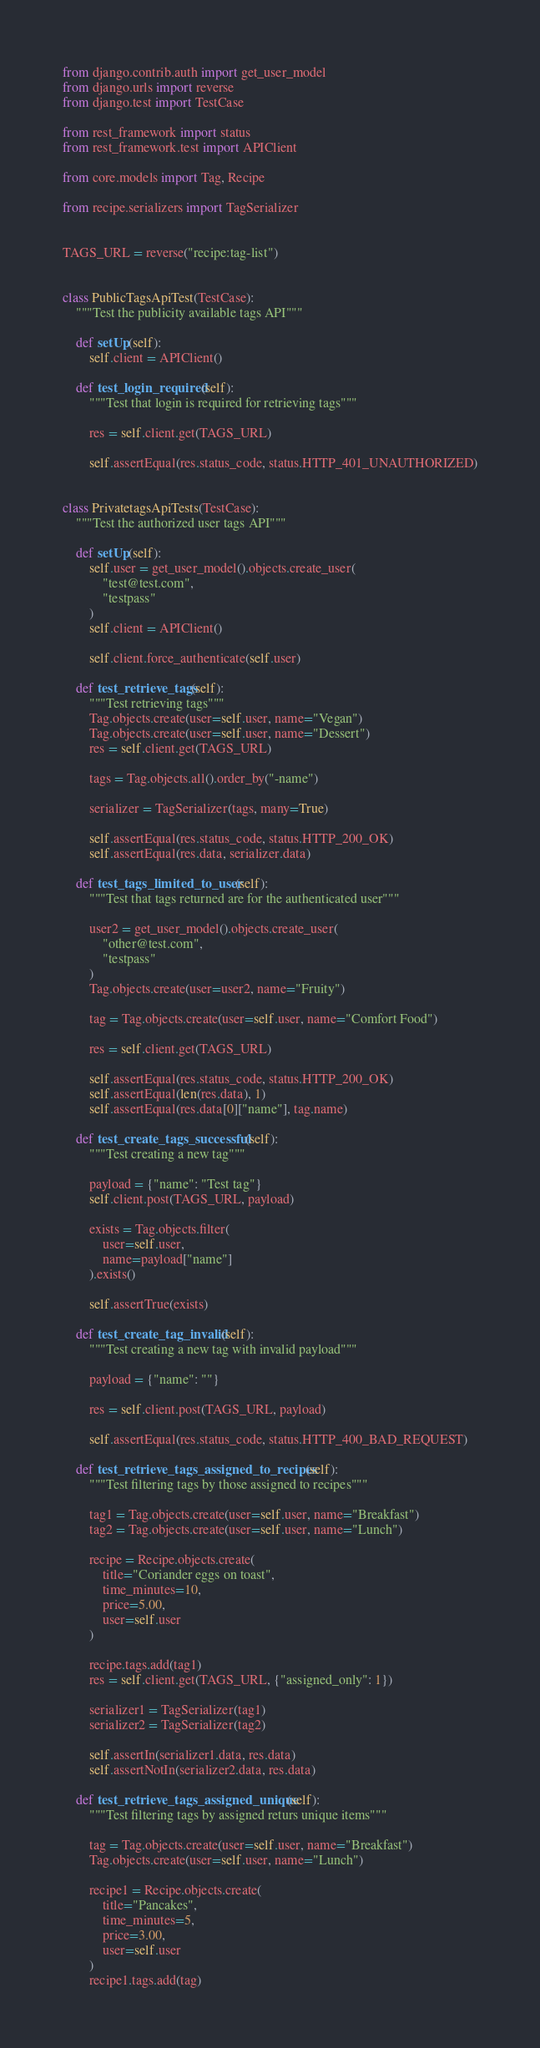<code> <loc_0><loc_0><loc_500><loc_500><_Python_>from django.contrib.auth import get_user_model
from django.urls import reverse
from django.test import TestCase

from rest_framework import status
from rest_framework.test import APIClient

from core.models import Tag, Recipe

from recipe.serializers import TagSerializer


TAGS_URL = reverse("recipe:tag-list")


class PublicTagsApiTest(TestCase):
    """Test the publicity available tags API"""

    def setUp(self):
        self.client = APIClient()

    def test_login_required(self):
        """Test that login is required for retrieving tags"""

        res = self.client.get(TAGS_URL)

        self.assertEqual(res.status_code, status.HTTP_401_UNAUTHORIZED)


class PrivatetagsApiTests(TestCase):
    """Test the authorized user tags API"""

    def setUp(self):
        self.user = get_user_model().objects.create_user(
            "test@test.com",
            "testpass"
        )
        self.client = APIClient()

        self.client.force_authenticate(self.user)

    def test_retrieve_tags(self):
        """Test retrieving tags"""
        Tag.objects.create(user=self.user, name="Vegan")
        Tag.objects.create(user=self.user, name="Dessert")
        res = self.client.get(TAGS_URL)

        tags = Tag.objects.all().order_by("-name")

        serializer = TagSerializer(tags, many=True)

        self.assertEqual(res.status_code, status.HTTP_200_OK)
        self.assertEqual(res.data, serializer.data)

    def test_tags_limited_to_user(self):
        """Test that tags returned are for the authenticated user"""

        user2 = get_user_model().objects.create_user(
            "other@test.com",
            "testpass"
        )
        Tag.objects.create(user=user2, name="Fruity")

        tag = Tag.objects.create(user=self.user, name="Comfort Food")

        res = self.client.get(TAGS_URL)

        self.assertEqual(res.status_code, status.HTTP_200_OK)
        self.assertEqual(len(res.data), 1)
        self.assertEqual(res.data[0]["name"], tag.name)

    def test_create_tags_successful(self):
        """Test creating a new tag"""

        payload = {"name": "Test tag"}
        self.client.post(TAGS_URL, payload)

        exists = Tag.objects.filter(
            user=self.user,
            name=payload["name"]
        ).exists()

        self.assertTrue(exists)

    def test_create_tag_invalid(self):
        """Test creating a new tag with invalid payload"""

        payload = {"name": ""}

        res = self.client.post(TAGS_URL, payload)

        self.assertEqual(res.status_code, status.HTTP_400_BAD_REQUEST)

    def test_retrieve_tags_assigned_to_recipes(self):
        """Test filtering tags by those assigned to recipes"""

        tag1 = Tag.objects.create(user=self.user, name="Breakfast")
        tag2 = Tag.objects.create(user=self.user, name="Lunch")

        recipe = Recipe.objects.create(
            title="Coriander eggs on toast",
            time_minutes=10,
            price=5.00,
            user=self.user
        )

        recipe.tags.add(tag1)
        res = self.client.get(TAGS_URL, {"assigned_only": 1})

        serializer1 = TagSerializer(tag1)
        serializer2 = TagSerializer(tag2)

        self.assertIn(serializer1.data, res.data)
        self.assertNotIn(serializer2.data, res.data)

    def test_retrieve_tags_assigned_unique(self):
        """Test filtering tags by assigned returs unique items"""

        tag = Tag.objects.create(user=self.user, name="Breakfast")
        Tag.objects.create(user=self.user, name="Lunch")

        recipe1 = Recipe.objects.create(
            title="Pancakes",
            time_minutes=5,
            price=3.00,
            user=self.user
        )
        recipe1.tags.add(tag)</code> 